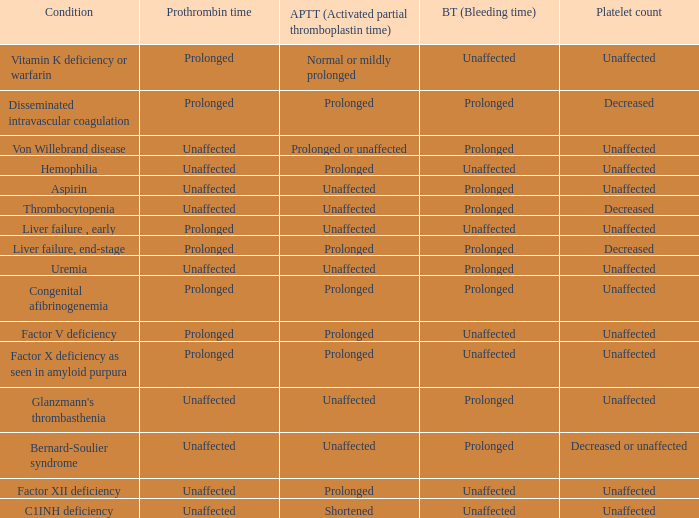Which Prothrombin time has a Platelet count of unaffected, and a Bleeding time of unaffected, and a Partial thromboplastin time of normal or mildly prolonged? Prolonged. 